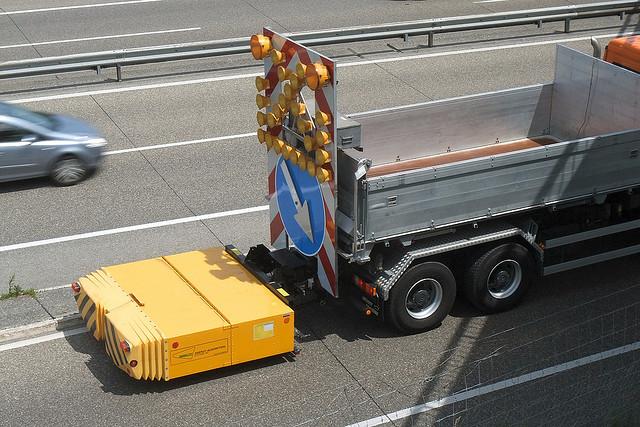Does this vehicle alert approaching traffic?
Concise answer only. Yes. What type of car is in the back?
Be succinct. Silver. How many lanes can be seen?
Short answer required. 4. 